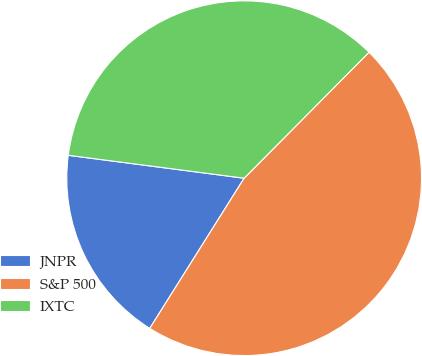Convert chart to OTSL. <chart><loc_0><loc_0><loc_500><loc_500><pie_chart><fcel>JNPR<fcel>S&P 500<fcel>IXTC<nl><fcel>18.13%<fcel>46.5%<fcel>35.37%<nl></chart> 